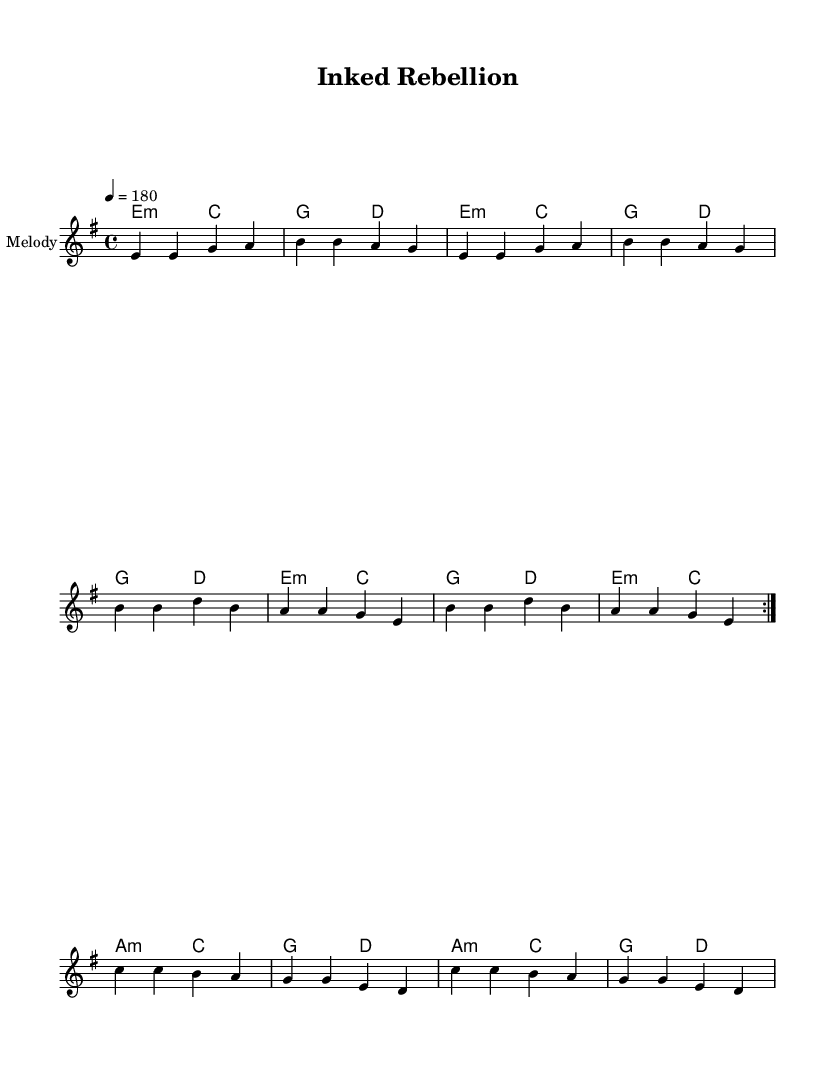What is the key signature of this music? The key signature is E minor, which has one sharp (F#). E minor is represented by the bold 'e' in the key signature at the start of the music.
Answer: E minor What is the time signature of this music? The time signature is 4/4, indicated at the beginning of the sheet music next to the key signature. This means there are four beats per measure, and the quarter note gets one beat.
Answer: 4/4 What is the tempo marking for this piece? The tempo marking is indicated as 4 = 180, which means to play at a speed where the quarter note gets 180 beats per minute. This is typically found at the beginning alongside the time signature.
Answer: 180 How many measures are in the chorus? The chorus consists of two measures, indicated by the chord symbols and the corresponding lyrics given after the verse. Counting them shows there are precisely two measures in this section.
Answer: 2 What is the primary theme of the lyrics? The primary theme revolves around freedom of expression and rebellion against censorship, as conveyed through phrases like "Let words be free" and "Ink runs dry." The lyrics discuss the importance of ideas growing despite attempts to silence them.
Answer: Freedom of expression Which chord is used at the start of the bridge? The bridge begins with an A minor chord. This can be identified in the chord mode section where the chords are indicated for each part of the piece.
Answer: A minor How does the melody repeat in the verse? The melody in the verse repeats in a volta form, meaning a specific section (the first set of measures with a repeat sign) is played twice before moving on to the chorus. This repetition highlights the verse's theme.
Answer: Twice 